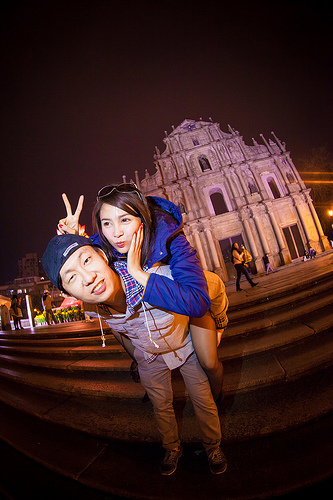<image>
Can you confirm if the man is behind the woman? No. The man is not behind the woman. From this viewpoint, the man appears to be positioned elsewhere in the scene. 